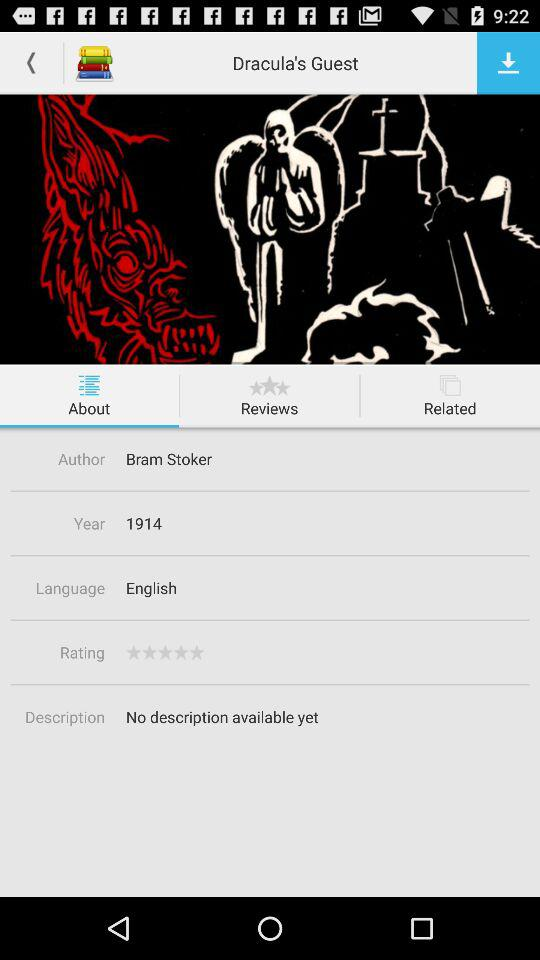What is the language? The language is English. 